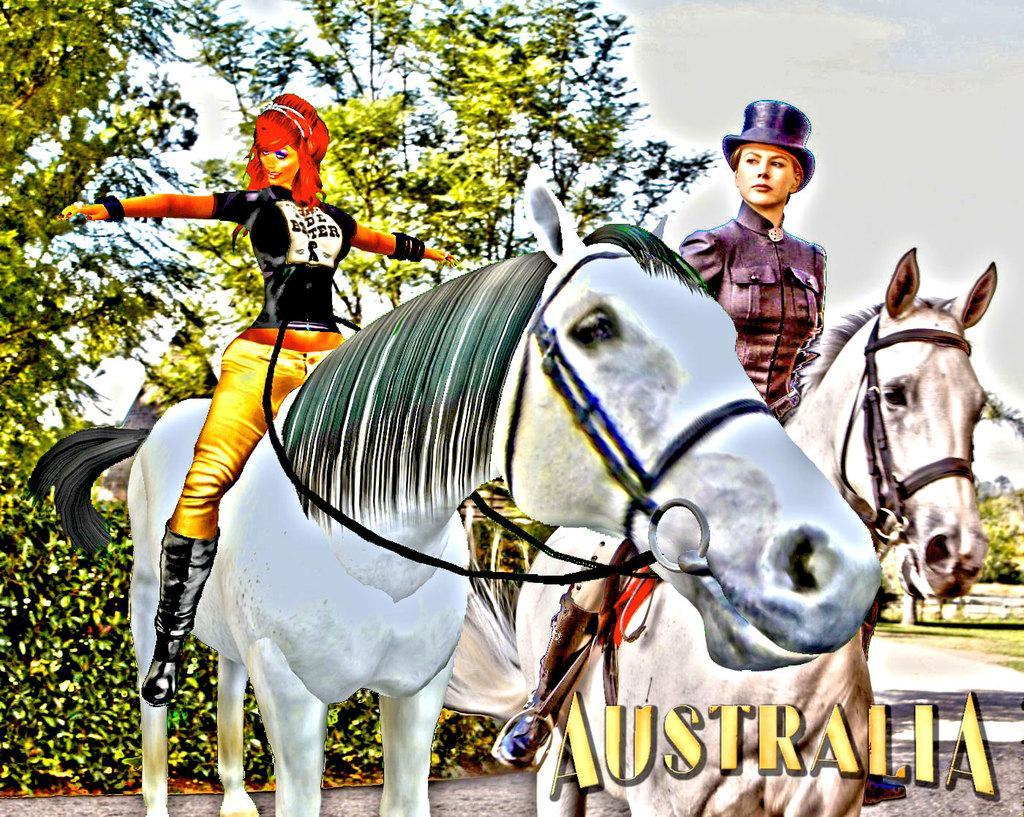In one or two sentences, can you explain what this image depicts? In this image we can see an animation. In the animation there are women sitting on the horses, road, bushes, trees and sky with clouds. 